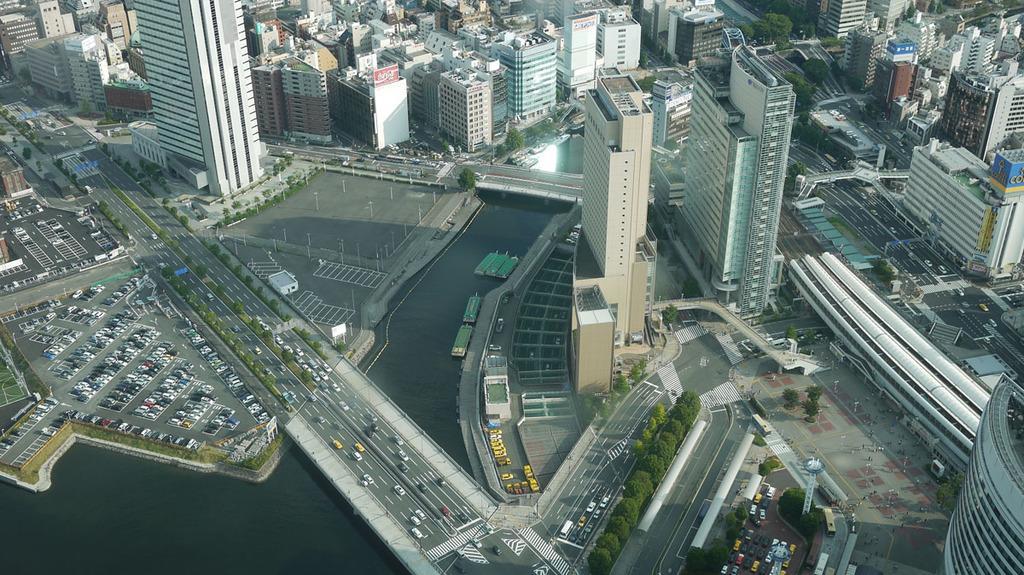Please provide a concise description of this image. In this picture there are few roads which has few vehicles on it and there are few boats on the water and there are few buildings and trees and there are few vehicles parked in parking place in the left corner. 